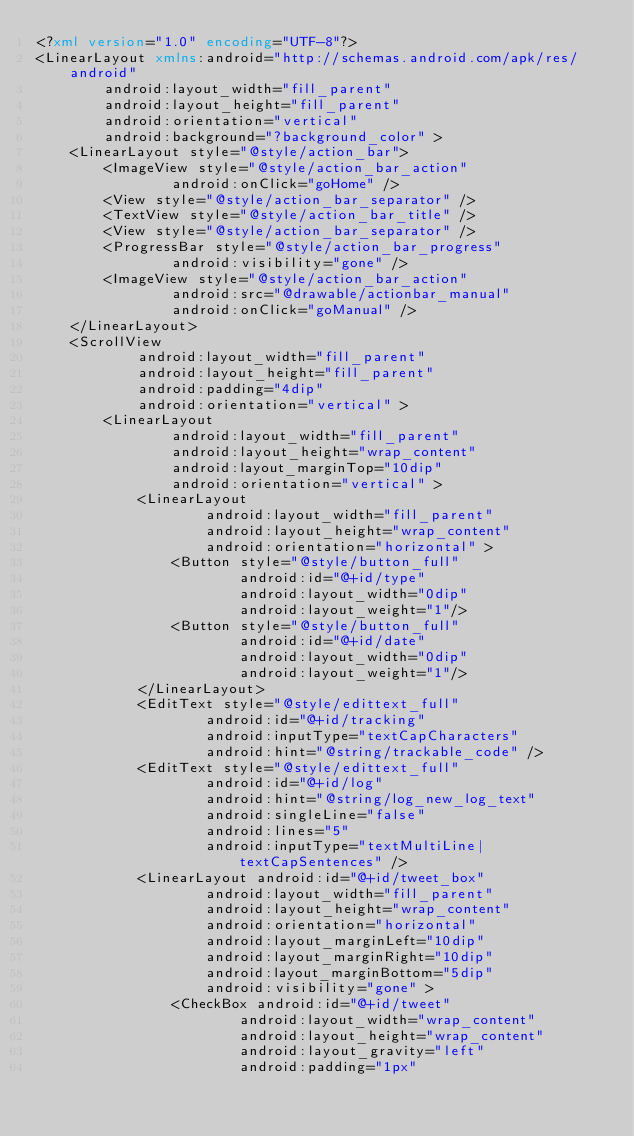Convert code to text. <code><loc_0><loc_0><loc_500><loc_500><_XML_><?xml version="1.0" encoding="UTF-8"?>
<LinearLayout xmlns:android="http://schemas.android.com/apk/res/android"
		android:layout_width="fill_parent"
		android:layout_height="fill_parent"
		android:orientation="vertical"
		android:background="?background_color" >
	<LinearLayout style="@style/action_bar">
		<ImageView style="@style/action_bar_action"
				android:onClick="goHome" />
		<View style="@style/action_bar_separator" />
		<TextView style="@style/action_bar_title" />
		<View style="@style/action_bar_separator" />
		<ProgressBar style="@style/action_bar_progress"
				android:visibility="gone" />
		<ImageView style="@style/action_bar_action"
				android:src="@drawable/actionbar_manual"
				android:onClick="goManual" />
	</LinearLayout>
	<ScrollView
			android:layout_width="fill_parent"
			android:layout_height="fill_parent"
			android:padding="4dip"
			android:orientation="vertical" >
		<LinearLayout
				android:layout_width="fill_parent"
				android:layout_height="wrap_content"
				android:layout_marginTop="10dip"
				android:orientation="vertical" >
			<LinearLayout
					android:layout_width="fill_parent"
					android:layout_height="wrap_content"
					android:orientation="horizontal" >
				<Button style="@style/button_full"
						android:id="@+id/type"
						android:layout_width="0dip"
						android:layout_weight="1"/>
				<Button style="@style/button_full"
						android:id="@+id/date"
						android:layout_width="0dip"
						android:layout_weight="1"/>
			</LinearLayout>
			<EditText style="@style/edittext_full"
					android:id="@+id/tracking"
					android:inputType="textCapCharacters"
					android:hint="@string/trackable_code" />
			<EditText style="@style/edittext_full"
					android:id="@+id/log"
                    android:hint="@string/log_new_log_text"
					android:singleLine="false"
					android:lines="5"
					android:inputType="textMultiLine|textCapSentences" />
			<LinearLayout android:id="@+id/tweet_box"
					android:layout_width="fill_parent"
					android:layout_height="wrap_content"
					android:orientation="horizontal"
					android:layout_marginLeft="10dip"
					android:layout_marginRight="10dip"
					android:layout_marginBottom="5dip"
					android:visibility="gone" >
				<CheckBox android:id="@+id/tweet"
						android:layout_width="wrap_content"
						android:layout_height="wrap_content"
						android:layout_gravity="left"
						android:padding="1px"</code> 